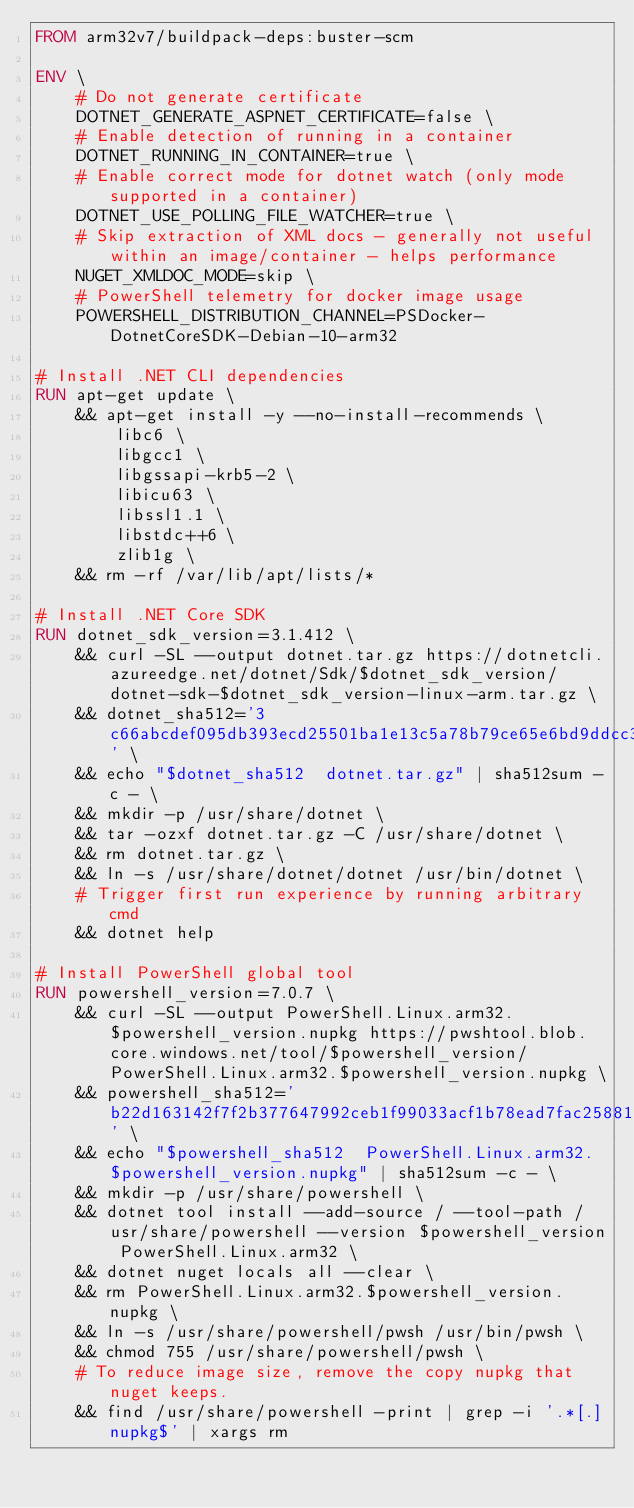Convert code to text. <code><loc_0><loc_0><loc_500><loc_500><_Dockerfile_>FROM arm32v7/buildpack-deps:buster-scm

ENV \
    # Do not generate certificate
    DOTNET_GENERATE_ASPNET_CERTIFICATE=false \
    # Enable detection of running in a container
    DOTNET_RUNNING_IN_CONTAINER=true \
    # Enable correct mode for dotnet watch (only mode supported in a container)
    DOTNET_USE_POLLING_FILE_WATCHER=true \
    # Skip extraction of XML docs - generally not useful within an image/container - helps performance
    NUGET_XMLDOC_MODE=skip \
    # PowerShell telemetry for docker image usage
    POWERSHELL_DISTRIBUTION_CHANNEL=PSDocker-DotnetCoreSDK-Debian-10-arm32

# Install .NET CLI dependencies
RUN apt-get update \
    && apt-get install -y --no-install-recommends \
        libc6 \
        libgcc1 \
        libgssapi-krb5-2 \
        libicu63 \
        libssl1.1 \
        libstdc++6 \
        zlib1g \
    && rm -rf /var/lib/apt/lists/*

# Install .NET Core SDK
RUN dotnet_sdk_version=3.1.412 \
    && curl -SL --output dotnet.tar.gz https://dotnetcli.azureedge.net/dotnet/Sdk/$dotnet_sdk_version/dotnet-sdk-$dotnet_sdk_version-linux-arm.tar.gz \
    && dotnet_sha512='3c66abcdef095db393ecd25501ba1e13c5a78b79ce65e6bd9ddcc3a559528eab21b0a95b39acb86e5f7f8565ae7a799e6c7e6d723121132110f93eb868cf81eb' \
    && echo "$dotnet_sha512  dotnet.tar.gz" | sha512sum -c - \
    && mkdir -p /usr/share/dotnet \
    && tar -ozxf dotnet.tar.gz -C /usr/share/dotnet \
    && rm dotnet.tar.gz \
    && ln -s /usr/share/dotnet/dotnet /usr/bin/dotnet \
    # Trigger first run experience by running arbitrary cmd
    && dotnet help

# Install PowerShell global tool
RUN powershell_version=7.0.7 \
    && curl -SL --output PowerShell.Linux.arm32.$powershell_version.nupkg https://pwshtool.blob.core.windows.net/tool/$powershell_version/PowerShell.Linux.arm32.$powershell_version.nupkg \
    && powershell_sha512='b22d163142f7f2b377647992ceb1f99033acf1b78ead7fac258816f3f36a5819aa6dd7143971861c571435c40719affd54b892d8397d8d1c8fdc3d347a2083d2' \
    && echo "$powershell_sha512  PowerShell.Linux.arm32.$powershell_version.nupkg" | sha512sum -c - \
    && mkdir -p /usr/share/powershell \
    && dotnet tool install --add-source / --tool-path /usr/share/powershell --version $powershell_version PowerShell.Linux.arm32 \
    && dotnet nuget locals all --clear \
    && rm PowerShell.Linux.arm32.$powershell_version.nupkg \
    && ln -s /usr/share/powershell/pwsh /usr/bin/pwsh \
    && chmod 755 /usr/share/powershell/pwsh \
    # To reduce image size, remove the copy nupkg that nuget keeps.
    && find /usr/share/powershell -print | grep -i '.*[.]nupkg$' | xargs rm
</code> 